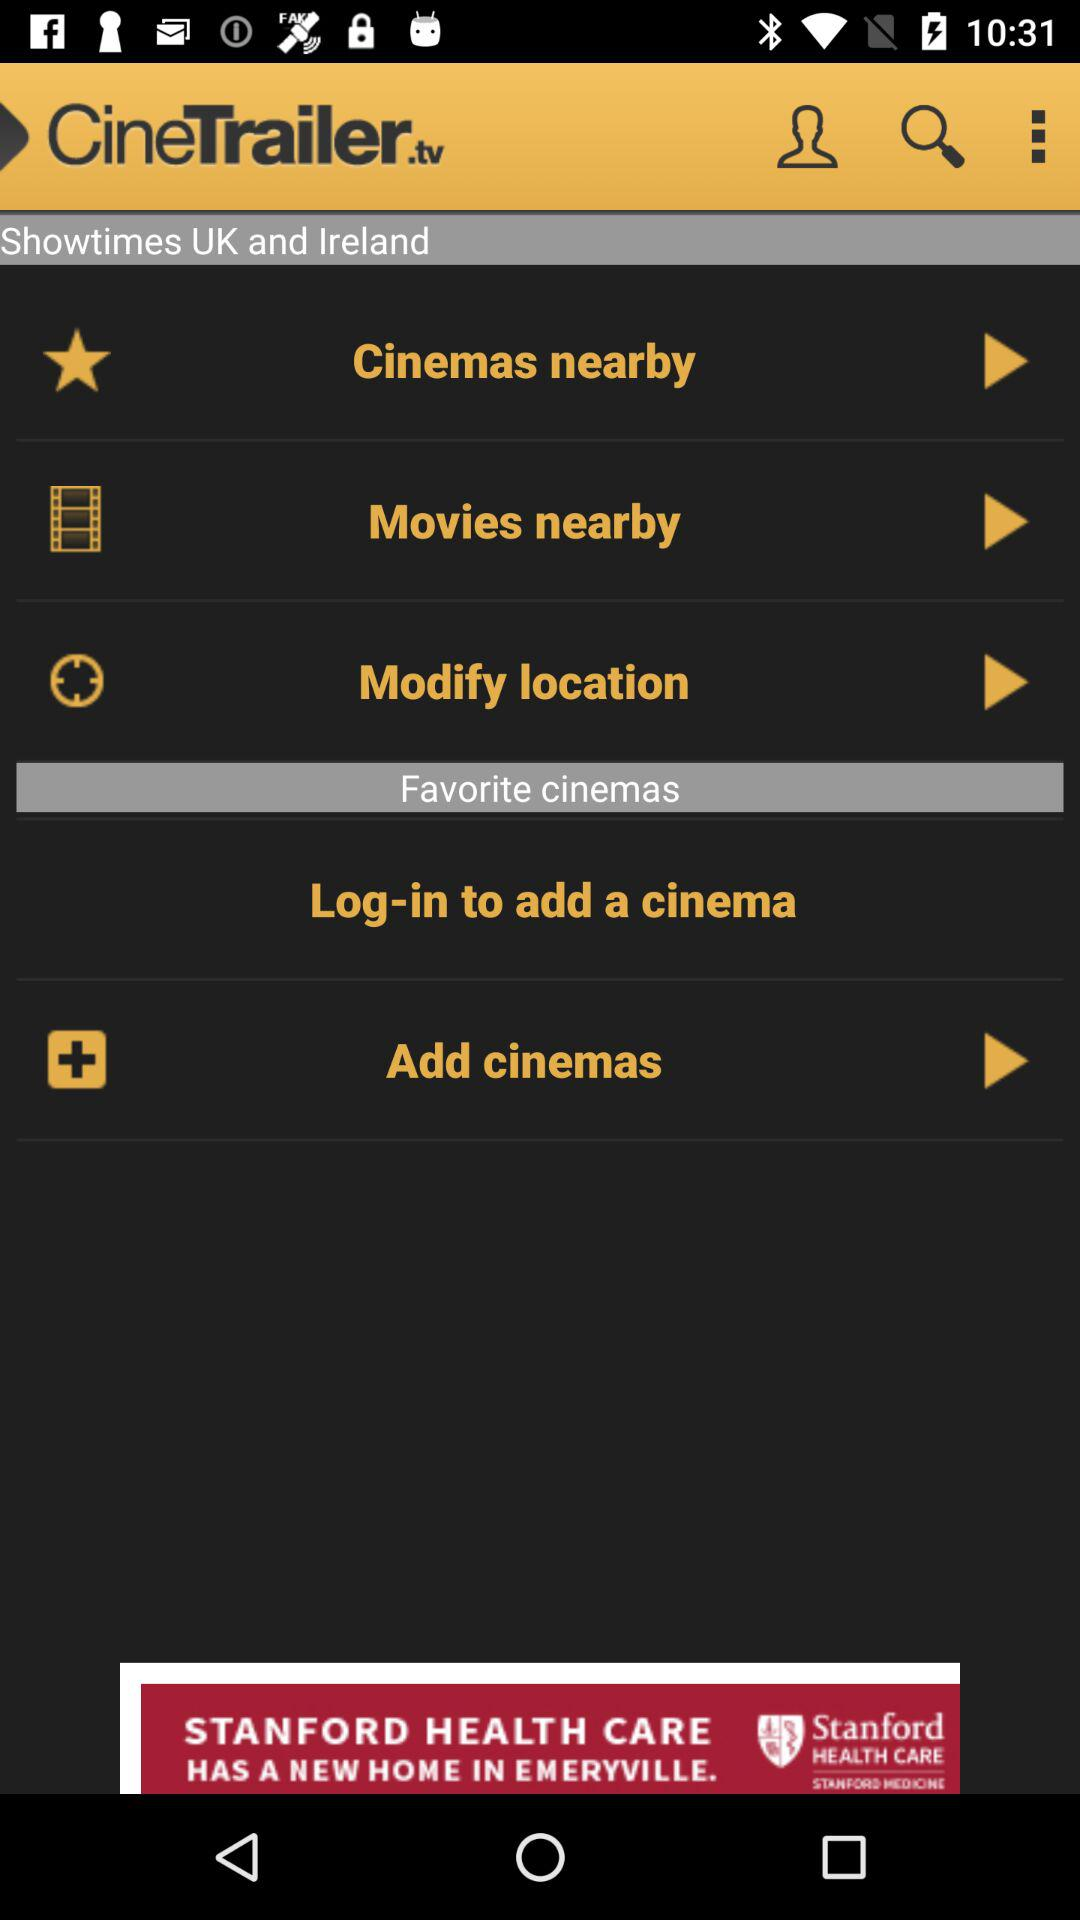What is the application name? The application name is "CineTrailer.tv". 